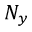<formula> <loc_0><loc_0><loc_500><loc_500>N _ { y }</formula> 